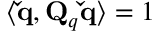<formula> <loc_0><loc_0><loc_500><loc_500>\langle \check { q } , Q _ { q } \check { q } \rangle = 1</formula> 